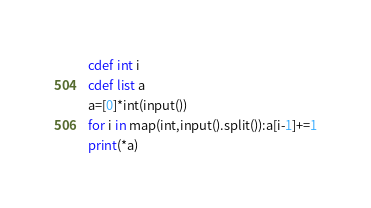Convert code to text. <code><loc_0><loc_0><loc_500><loc_500><_Cython_>cdef int i
cdef list a
a=[0]*int(input())
for i in map(int,input().split()):a[i-1]+=1
print(*a)</code> 